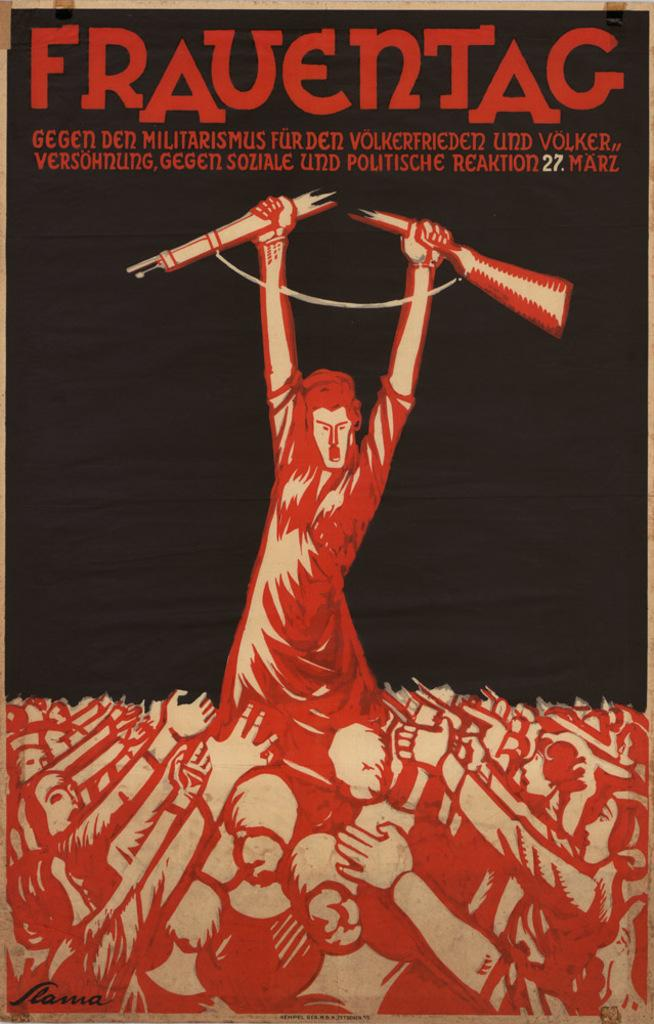What type of visual is the image? The image is a poster. What is the main subject in the middle of the poster? There is a person holding a broken gun in the middle of the poster. How many people are depicted at the bottom of the poster? There are many people at the bottom of the poster. Where are the texts located on the poster? The texts are at the top of the poster. What type of flower is growing at the top of the poster? There is no flower present at the top of the poster; it contains texts instead. 